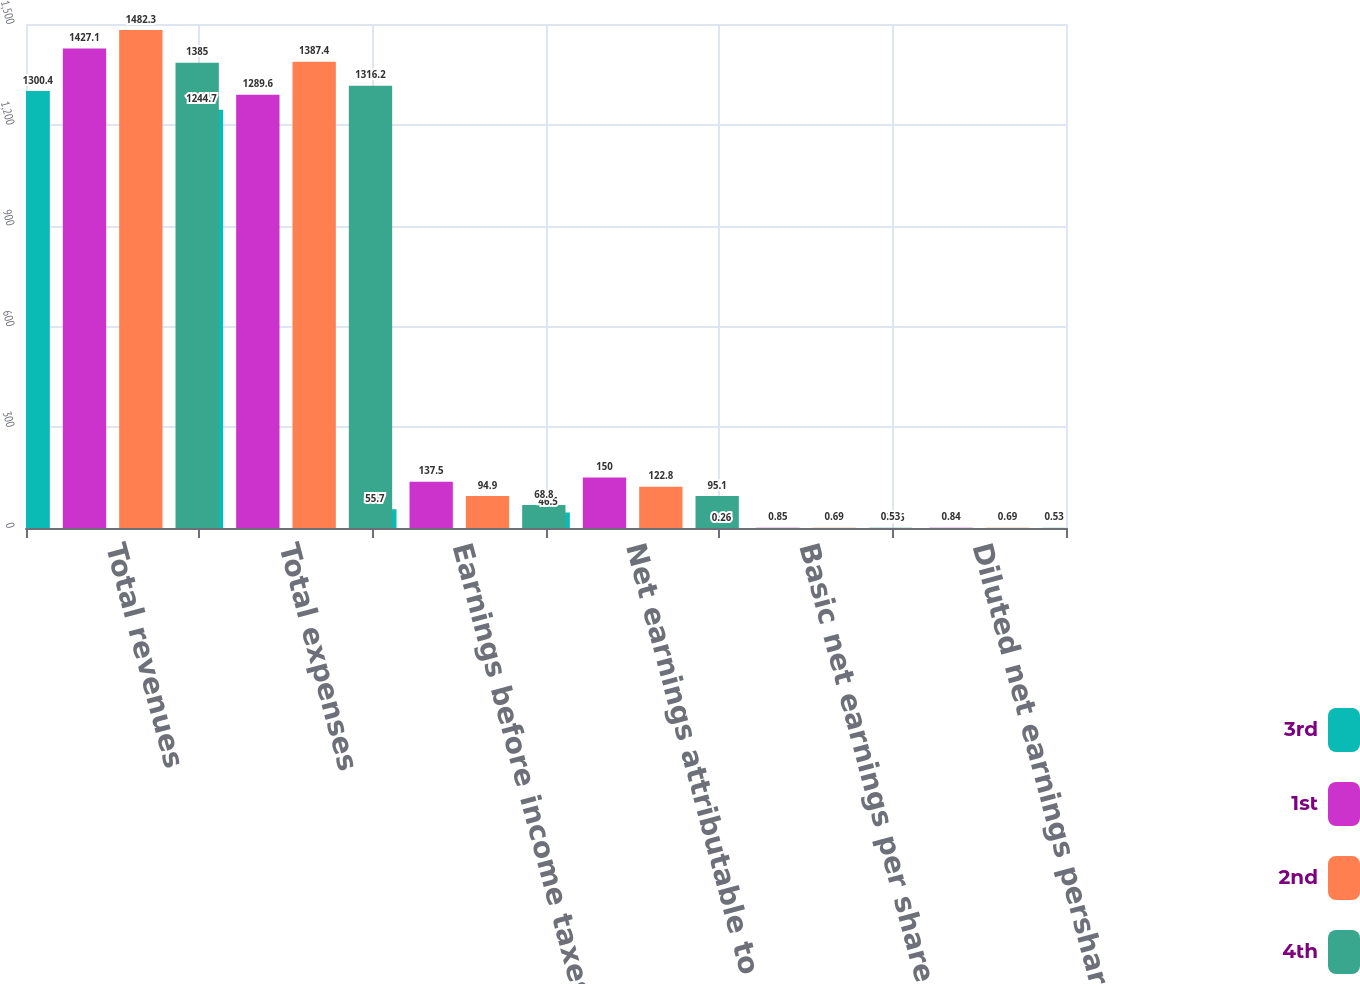<chart> <loc_0><loc_0><loc_500><loc_500><stacked_bar_chart><ecel><fcel>Total revenues<fcel>Total expenses<fcel>Earnings before income taxes<fcel>Net earnings attributable to<fcel>Basic net earnings per share<fcel>Diluted net earnings pershare<nl><fcel>3rd<fcel>1300.4<fcel>1244.7<fcel>55.7<fcel>46.5<fcel>0.26<fcel>0.26<nl><fcel>1st<fcel>1427.1<fcel>1289.6<fcel>137.5<fcel>150<fcel>0.85<fcel>0.84<nl><fcel>2nd<fcel>1482.3<fcel>1387.4<fcel>94.9<fcel>122.8<fcel>0.69<fcel>0.69<nl><fcel>4th<fcel>1385<fcel>1316.2<fcel>68.8<fcel>95.1<fcel>0.53<fcel>0.53<nl></chart> 